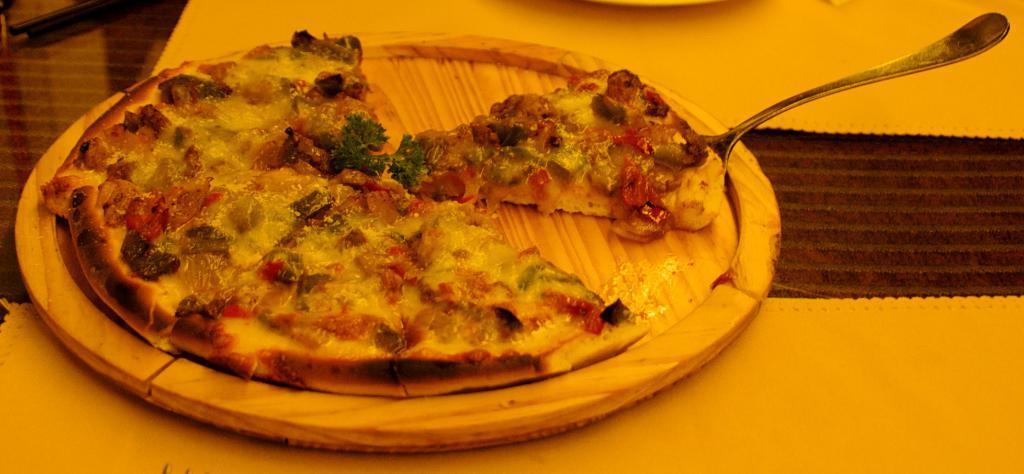Describe this image in one or two sentences. In this image there is a wooden plate on which there is a pizza. On the right side there is a piece of pizza on the spoon. 